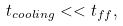<formula> <loc_0><loc_0><loc_500><loc_500>t _ { c o o l i n g } < < t _ { f f } ,</formula> 